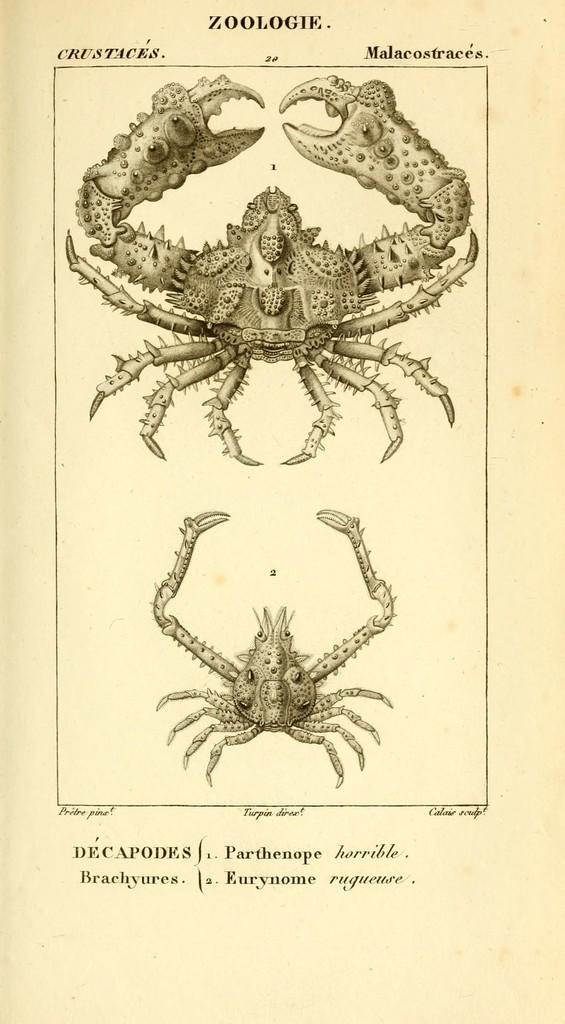Can you describe this image briefly? In this image we can see a page from a book, where we can see two Scorpios and text at the top and bottom of the page. 